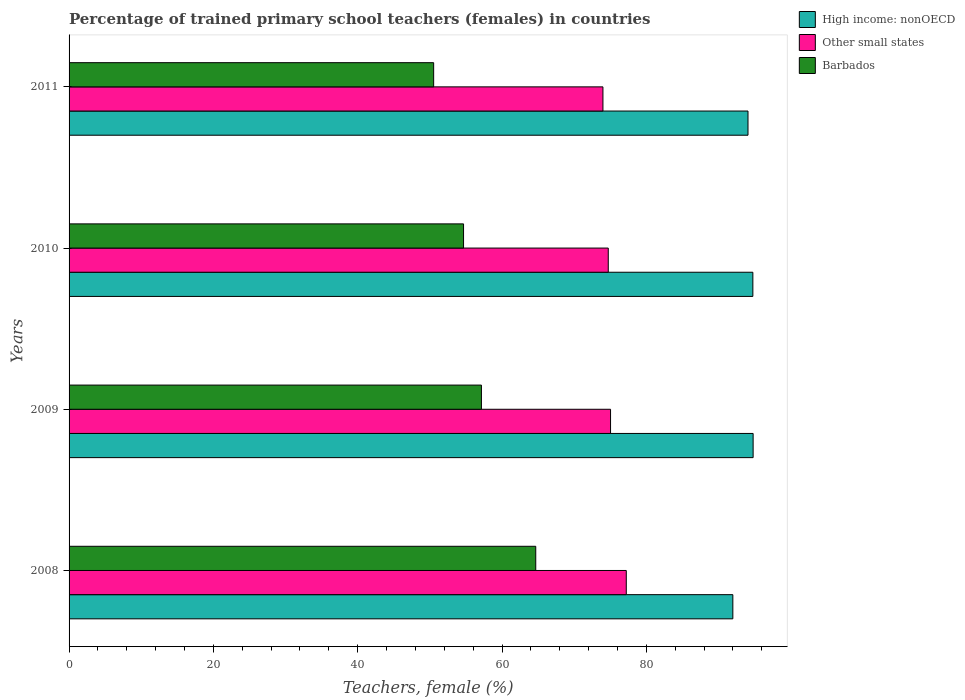How many groups of bars are there?
Your response must be concise. 4. Are the number of bars per tick equal to the number of legend labels?
Make the answer very short. Yes. How many bars are there on the 4th tick from the top?
Your answer should be very brief. 3. In how many cases, is the number of bars for a given year not equal to the number of legend labels?
Your response must be concise. 0. What is the percentage of trained primary school teachers (females) in High income: nonOECD in 2008?
Offer a very short reply. 91.99. Across all years, what is the maximum percentage of trained primary school teachers (females) in Other small states?
Offer a terse response. 77.22. Across all years, what is the minimum percentage of trained primary school teachers (females) in High income: nonOECD?
Your response must be concise. 91.99. What is the total percentage of trained primary school teachers (females) in High income: nonOECD in the graph?
Offer a terse response. 375.62. What is the difference between the percentage of trained primary school teachers (females) in Other small states in 2008 and that in 2010?
Your answer should be very brief. 2.5. What is the difference between the percentage of trained primary school teachers (females) in Other small states in 2009 and the percentage of trained primary school teachers (females) in Barbados in 2008?
Provide a succinct answer. 10.36. What is the average percentage of trained primary school teachers (females) in Other small states per year?
Offer a very short reply. 75.24. In the year 2010, what is the difference between the percentage of trained primary school teachers (females) in Other small states and percentage of trained primary school teachers (females) in Barbados?
Your answer should be compact. 20.05. What is the ratio of the percentage of trained primary school teachers (females) in Other small states in 2008 to that in 2010?
Make the answer very short. 1.03. Is the difference between the percentage of trained primary school teachers (females) in Other small states in 2009 and 2010 greater than the difference between the percentage of trained primary school teachers (females) in Barbados in 2009 and 2010?
Make the answer very short. No. What is the difference between the highest and the second highest percentage of trained primary school teachers (females) in Other small states?
Provide a succinct answer. 2.18. What is the difference between the highest and the lowest percentage of trained primary school teachers (females) in Other small states?
Keep it short and to the point. 3.23. In how many years, is the percentage of trained primary school teachers (females) in High income: nonOECD greater than the average percentage of trained primary school teachers (females) in High income: nonOECD taken over all years?
Provide a succinct answer. 3. What does the 3rd bar from the top in 2010 represents?
Your response must be concise. High income: nonOECD. What does the 2nd bar from the bottom in 2010 represents?
Provide a succinct answer. Other small states. Is it the case that in every year, the sum of the percentage of trained primary school teachers (females) in Barbados and percentage of trained primary school teachers (females) in Other small states is greater than the percentage of trained primary school teachers (females) in High income: nonOECD?
Your response must be concise. Yes. How many bars are there?
Your response must be concise. 12. What is the difference between two consecutive major ticks on the X-axis?
Give a very brief answer. 20. Are the values on the major ticks of X-axis written in scientific E-notation?
Your answer should be compact. No. Does the graph contain any zero values?
Offer a terse response. No. Does the graph contain grids?
Offer a very short reply. No. Where does the legend appear in the graph?
Keep it short and to the point. Top right. How many legend labels are there?
Make the answer very short. 3. How are the legend labels stacked?
Your response must be concise. Vertical. What is the title of the graph?
Provide a short and direct response. Percentage of trained primary school teachers (females) in countries. Does "Fiji" appear as one of the legend labels in the graph?
Offer a very short reply. No. What is the label or title of the X-axis?
Keep it short and to the point. Teachers, female (%). What is the label or title of the Y-axis?
Offer a very short reply. Years. What is the Teachers, female (%) of High income: nonOECD in 2008?
Make the answer very short. 91.99. What is the Teachers, female (%) in Other small states in 2008?
Your answer should be compact. 77.22. What is the Teachers, female (%) of Barbados in 2008?
Offer a very short reply. 64.67. What is the Teachers, female (%) in High income: nonOECD in 2009?
Ensure brevity in your answer.  94.79. What is the Teachers, female (%) of Other small states in 2009?
Your answer should be compact. 75.04. What is the Teachers, female (%) in Barbados in 2009?
Give a very brief answer. 57.14. What is the Teachers, female (%) of High income: nonOECD in 2010?
Your answer should be very brief. 94.76. What is the Teachers, female (%) in Other small states in 2010?
Provide a succinct answer. 74.72. What is the Teachers, female (%) in Barbados in 2010?
Give a very brief answer. 54.67. What is the Teachers, female (%) of High income: nonOECD in 2011?
Offer a very short reply. 94.08. What is the Teachers, female (%) in Other small states in 2011?
Offer a terse response. 73.98. What is the Teachers, female (%) in Barbados in 2011?
Offer a terse response. 50.52. Across all years, what is the maximum Teachers, female (%) in High income: nonOECD?
Your answer should be compact. 94.79. Across all years, what is the maximum Teachers, female (%) of Other small states?
Your answer should be compact. 77.22. Across all years, what is the maximum Teachers, female (%) of Barbados?
Give a very brief answer. 64.67. Across all years, what is the minimum Teachers, female (%) of High income: nonOECD?
Give a very brief answer. 91.99. Across all years, what is the minimum Teachers, female (%) in Other small states?
Give a very brief answer. 73.98. Across all years, what is the minimum Teachers, female (%) of Barbados?
Give a very brief answer. 50.52. What is the total Teachers, female (%) in High income: nonOECD in the graph?
Give a very brief answer. 375.62. What is the total Teachers, female (%) in Other small states in the graph?
Provide a succinct answer. 300.96. What is the total Teachers, female (%) in Barbados in the graph?
Ensure brevity in your answer.  227.01. What is the difference between the Teachers, female (%) of High income: nonOECD in 2008 and that in 2009?
Give a very brief answer. -2.81. What is the difference between the Teachers, female (%) of Other small states in 2008 and that in 2009?
Provide a succinct answer. 2.18. What is the difference between the Teachers, female (%) in Barbados in 2008 and that in 2009?
Make the answer very short. 7.53. What is the difference between the Teachers, female (%) in High income: nonOECD in 2008 and that in 2010?
Provide a succinct answer. -2.77. What is the difference between the Teachers, female (%) of Other small states in 2008 and that in 2010?
Offer a very short reply. 2.5. What is the difference between the Teachers, female (%) of Barbados in 2008 and that in 2010?
Your response must be concise. 10.01. What is the difference between the Teachers, female (%) in High income: nonOECD in 2008 and that in 2011?
Give a very brief answer. -2.1. What is the difference between the Teachers, female (%) of Other small states in 2008 and that in 2011?
Provide a succinct answer. 3.23. What is the difference between the Teachers, female (%) in Barbados in 2008 and that in 2011?
Your answer should be compact. 14.15. What is the difference between the Teachers, female (%) of High income: nonOECD in 2009 and that in 2010?
Your answer should be very brief. 0.04. What is the difference between the Teachers, female (%) in Other small states in 2009 and that in 2010?
Keep it short and to the point. 0.32. What is the difference between the Teachers, female (%) of Barbados in 2009 and that in 2010?
Offer a very short reply. 2.48. What is the difference between the Teachers, female (%) in High income: nonOECD in 2009 and that in 2011?
Your response must be concise. 0.71. What is the difference between the Teachers, female (%) of Other small states in 2009 and that in 2011?
Keep it short and to the point. 1.05. What is the difference between the Teachers, female (%) of Barbados in 2009 and that in 2011?
Make the answer very short. 6.62. What is the difference between the Teachers, female (%) of High income: nonOECD in 2010 and that in 2011?
Your answer should be compact. 0.67. What is the difference between the Teachers, female (%) in Other small states in 2010 and that in 2011?
Give a very brief answer. 0.74. What is the difference between the Teachers, female (%) of Barbados in 2010 and that in 2011?
Your answer should be compact. 4.14. What is the difference between the Teachers, female (%) in High income: nonOECD in 2008 and the Teachers, female (%) in Other small states in 2009?
Make the answer very short. 16.95. What is the difference between the Teachers, female (%) in High income: nonOECD in 2008 and the Teachers, female (%) in Barbados in 2009?
Give a very brief answer. 34.84. What is the difference between the Teachers, female (%) of Other small states in 2008 and the Teachers, female (%) of Barbados in 2009?
Make the answer very short. 20.07. What is the difference between the Teachers, female (%) in High income: nonOECD in 2008 and the Teachers, female (%) in Other small states in 2010?
Offer a very short reply. 17.26. What is the difference between the Teachers, female (%) in High income: nonOECD in 2008 and the Teachers, female (%) in Barbados in 2010?
Provide a succinct answer. 37.32. What is the difference between the Teachers, female (%) of Other small states in 2008 and the Teachers, female (%) of Barbados in 2010?
Make the answer very short. 22.55. What is the difference between the Teachers, female (%) of High income: nonOECD in 2008 and the Teachers, female (%) of Other small states in 2011?
Make the answer very short. 18. What is the difference between the Teachers, female (%) of High income: nonOECD in 2008 and the Teachers, female (%) of Barbados in 2011?
Offer a very short reply. 41.46. What is the difference between the Teachers, female (%) in Other small states in 2008 and the Teachers, female (%) in Barbados in 2011?
Offer a terse response. 26.69. What is the difference between the Teachers, female (%) in High income: nonOECD in 2009 and the Teachers, female (%) in Other small states in 2010?
Your answer should be very brief. 20.07. What is the difference between the Teachers, female (%) of High income: nonOECD in 2009 and the Teachers, female (%) of Barbados in 2010?
Ensure brevity in your answer.  40.13. What is the difference between the Teachers, female (%) in Other small states in 2009 and the Teachers, female (%) in Barbados in 2010?
Your answer should be very brief. 20.37. What is the difference between the Teachers, female (%) of High income: nonOECD in 2009 and the Teachers, female (%) of Other small states in 2011?
Make the answer very short. 20.81. What is the difference between the Teachers, female (%) in High income: nonOECD in 2009 and the Teachers, female (%) in Barbados in 2011?
Provide a succinct answer. 44.27. What is the difference between the Teachers, female (%) in Other small states in 2009 and the Teachers, female (%) in Barbados in 2011?
Your answer should be very brief. 24.51. What is the difference between the Teachers, female (%) in High income: nonOECD in 2010 and the Teachers, female (%) in Other small states in 2011?
Ensure brevity in your answer.  20.78. What is the difference between the Teachers, female (%) of High income: nonOECD in 2010 and the Teachers, female (%) of Barbados in 2011?
Provide a succinct answer. 44.23. What is the difference between the Teachers, female (%) in Other small states in 2010 and the Teachers, female (%) in Barbados in 2011?
Your response must be concise. 24.2. What is the average Teachers, female (%) in High income: nonOECD per year?
Your answer should be very brief. 93.91. What is the average Teachers, female (%) in Other small states per year?
Your response must be concise. 75.24. What is the average Teachers, female (%) of Barbados per year?
Your answer should be compact. 56.75. In the year 2008, what is the difference between the Teachers, female (%) in High income: nonOECD and Teachers, female (%) in Other small states?
Provide a short and direct response. 14.77. In the year 2008, what is the difference between the Teachers, female (%) in High income: nonOECD and Teachers, female (%) in Barbados?
Ensure brevity in your answer.  27.31. In the year 2008, what is the difference between the Teachers, female (%) of Other small states and Teachers, female (%) of Barbados?
Ensure brevity in your answer.  12.54. In the year 2009, what is the difference between the Teachers, female (%) in High income: nonOECD and Teachers, female (%) in Other small states?
Give a very brief answer. 19.76. In the year 2009, what is the difference between the Teachers, female (%) of High income: nonOECD and Teachers, female (%) of Barbados?
Keep it short and to the point. 37.65. In the year 2009, what is the difference between the Teachers, female (%) in Other small states and Teachers, female (%) in Barbados?
Your answer should be very brief. 17.89. In the year 2010, what is the difference between the Teachers, female (%) of High income: nonOECD and Teachers, female (%) of Other small states?
Give a very brief answer. 20.04. In the year 2010, what is the difference between the Teachers, female (%) of High income: nonOECD and Teachers, female (%) of Barbados?
Your answer should be very brief. 40.09. In the year 2010, what is the difference between the Teachers, female (%) of Other small states and Teachers, female (%) of Barbados?
Provide a succinct answer. 20.05. In the year 2011, what is the difference between the Teachers, female (%) in High income: nonOECD and Teachers, female (%) in Other small states?
Ensure brevity in your answer.  20.1. In the year 2011, what is the difference between the Teachers, female (%) in High income: nonOECD and Teachers, female (%) in Barbados?
Your answer should be very brief. 43.56. In the year 2011, what is the difference between the Teachers, female (%) in Other small states and Teachers, female (%) in Barbados?
Provide a succinct answer. 23.46. What is the ratio of the Teachers, female (%) of High income: nonOECD in 2008 to that in 2009?
Your answer should be very brief. 0.97. What is the ratio of the Teachers, female (%) in Other small states in 2008 to that in 2009?
Ensure brevity in your answer.  1.03. What is the ratio of the Teachers, female (%) of Barbados in 2008 to that in 2009?
Keep it short and to the point. 1.13. What is the ratio of the Teachers, female (%) of High income: nonOECD in 2008 to that in 2010?
Ensure brevity in your answer.  0.97. What is the ratio of the Teachers, female (%) of Other small states in 2008 to that in 2010?
Offer a terse response. 1.03. What is the ratio of the Teachers, female (%) in Barbados in 2008 to that in 2010?
Provide a short and direct response. 1.18. What is the ratio of the Teachers, female (%) of High income: nonOECD in 2008 to that in 2011?
Make the answer very short. 0.98. What is the ratio of the Teachers, female (%) in Other small states in 2008 to that in 2011?
Ensure brevity in your answer.  1.04. What is the ratio of the Teachers, female (%) in Barbados in 2008 to that in 2011?
Provide a succinct answer. 1.28. What is the ratio of the Teachers, female (%) of Barbados in 2009 to that in 2010?
Provide a short and direct response. 1.05. What is the ratio of the Teachers, female (%) in High income: nonOECD in 2009 to that in 2011?
Provide a short and direct response. 1.01. What is the ratio of the Teachers, female (%) in Other small states in 2009 to that in 2011?
Make the answer very short. 1.01. What is the ratio of the Teachers, female (%) in Barbados in 2009 to that in 2011?
Offer a very short reply. 1.13. What is the ratio of the Teachers, female (%) of Other small states in 2010 to that in 2011?
Your response must be concise. 1.01. What is the ratio of the Teachers, female (%) of Barbados in 2010 to that in 2011?
Your answer should be very brief. 1.08. What is the difference between the highest and the second highest Teachers, female (%) in High income: nonOECD?
Offer a very short reply. 0.04. What is the difference between the highest and the second highest Teachers, female (%) in Other small states?
Your answer should be very brief. 2.18. What is the difference between the highest and the second highest Teachers, female (%) in Barbados?
Give a very brief answer. 7.53. What is the difference between the highest and the lowest Teachers, female (%) in High income: nonOECD?
Keep it short and to the point. 2.81. What is the difference between the highest and the lowest Teachers, female (%) in Other small states?
Give a very brief answer. 3.23. What is the difference between the highest and the lowest Teachers, female (%) of Barbados?
Offer a very short reply. 14.15. 